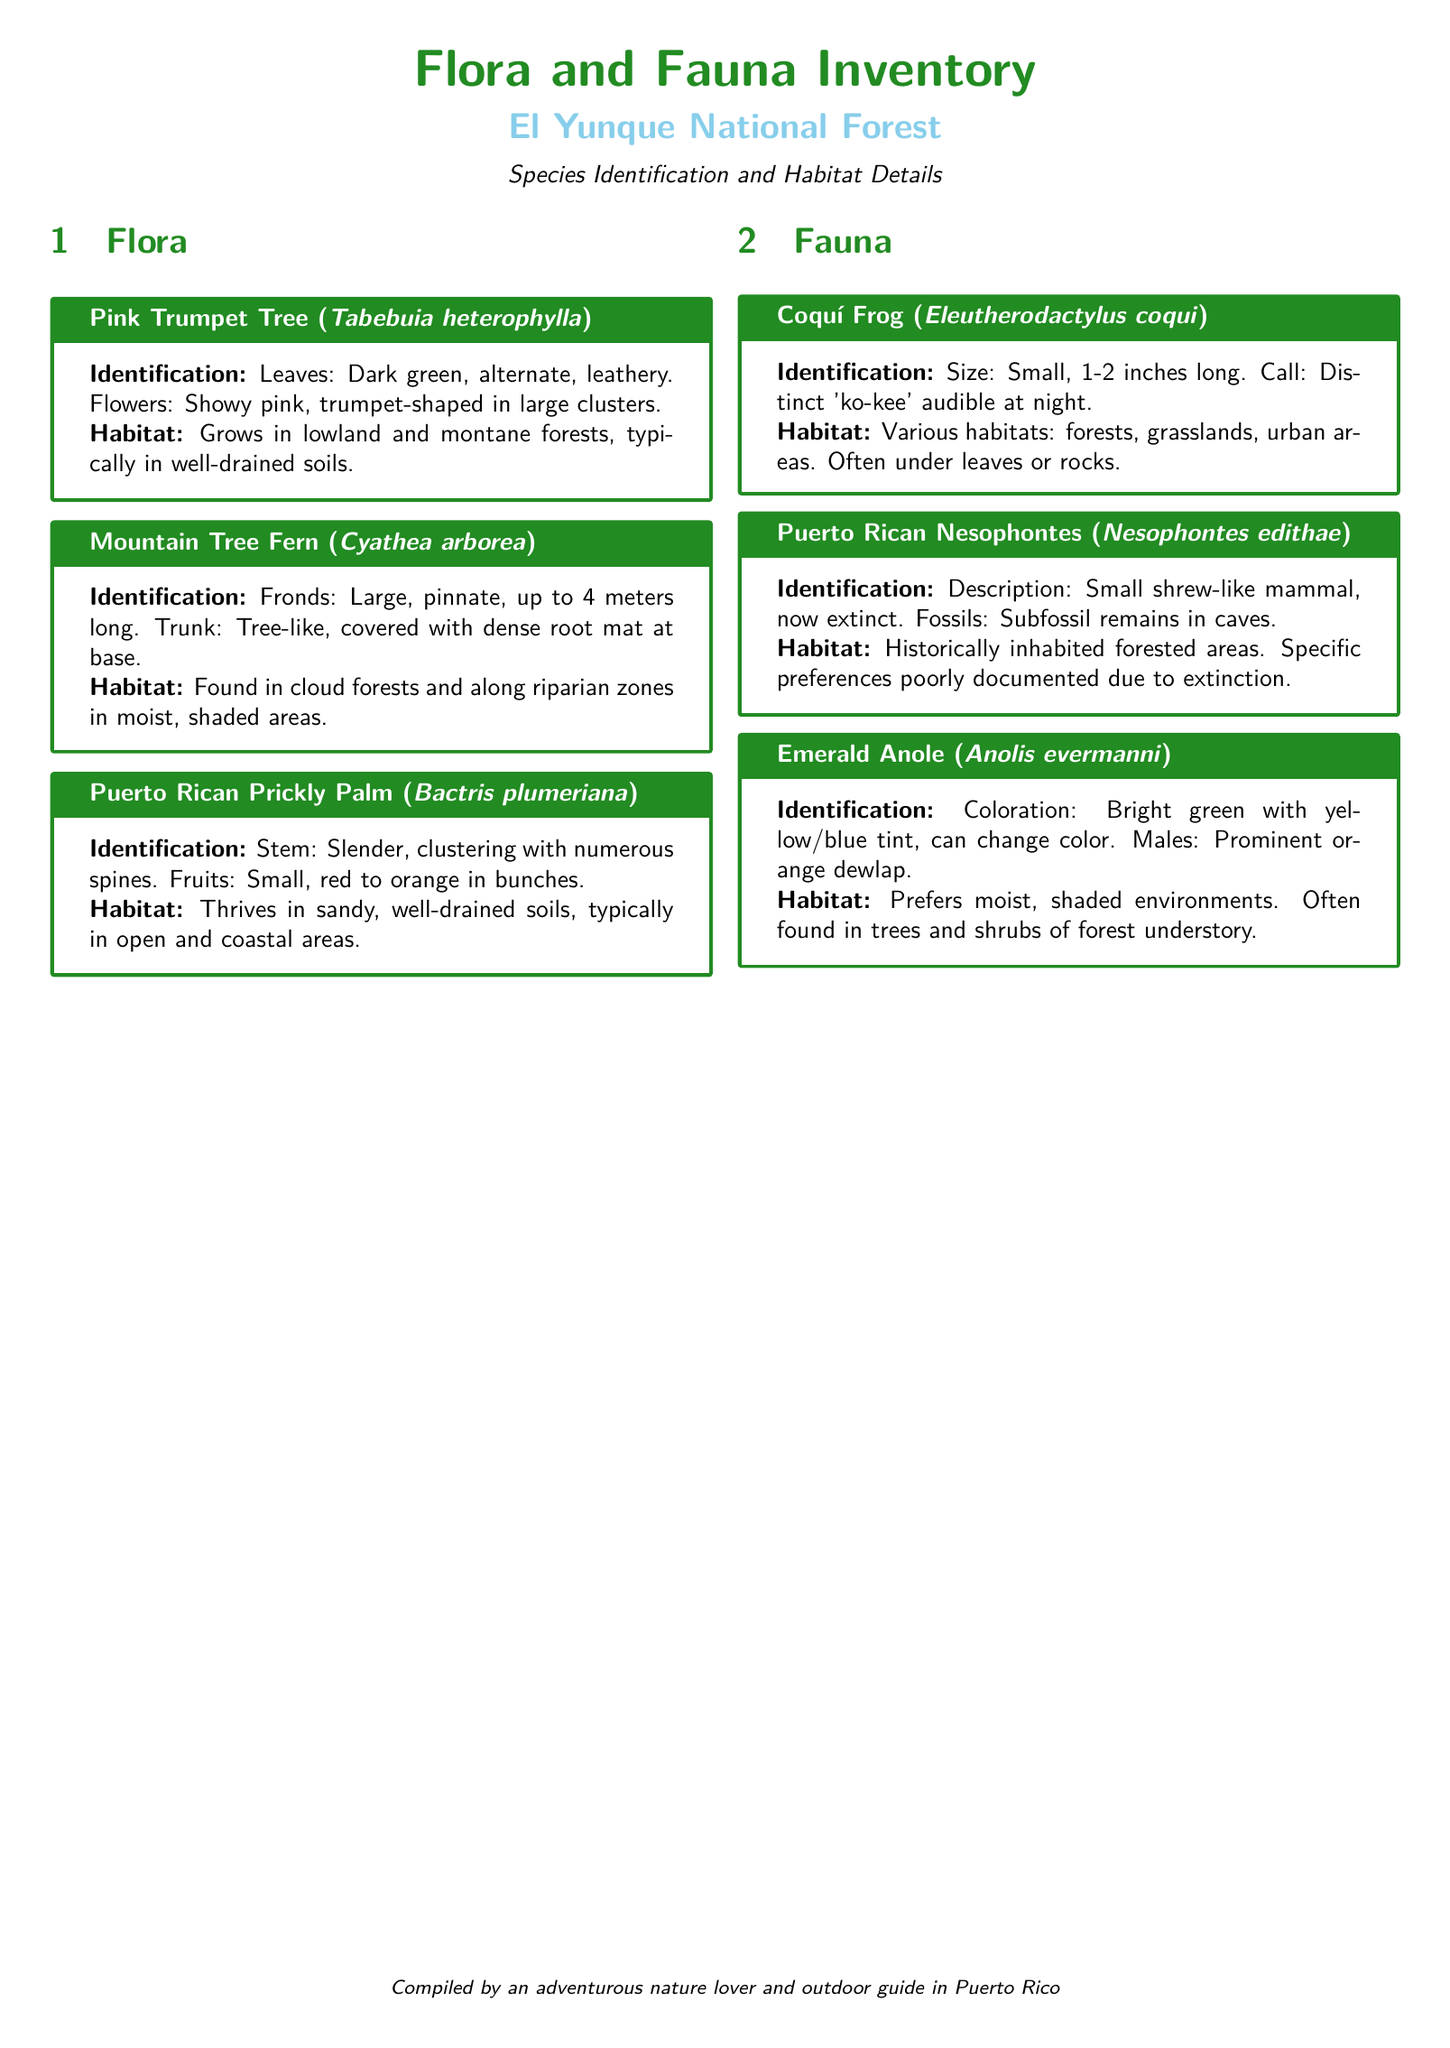What is the scientific name of the Pink Trumpet Tree? The scientific name is provided in the document under the species section for Pink Trumpet Tree.
Answer: Tabebuia heterophylla How long can the fronds of the Mountain Tree Fern grow? The frond length is given as a specific measure in the identification section of the Mountain Tree Fern.
Answer: Up to 4 meters long What significant characteristic identifies the Coquí Frog? The distinctive feature of the Coquí Frog is included in its identification section.
Answer: Distinct 'ko-kee' call In which types of environments does the Emerald Anole prefer to live? The preferred habitat of the Emerald Anole is detailed in the habitat section of its description.
Answer: Moist, shaded environments Which species is described as having a slender, clustering stem with spines? The description mentions specific characteristics of a species under the flora section.
Answer: Puerto Rican Prickly Palm How many animals are listed in the fauna section? The fauna section contains specific entries which can be counted.
Answer: Three What is the color of the Emerald Anole's dewlap? The dewlap color is detailed in the identification of the Emerald Anole.
Answer: Orange What type of forest is the Mountain Tree Fern found in? The specific habitat type for the Mountain Tree Fern is provided in the habitat details.
Answer: Cloud forests Which species is now extinct according to the document? The document indicates one species is extinct and provides its name in the fauna section.
Answer: Puerto Rican Nesophontes 